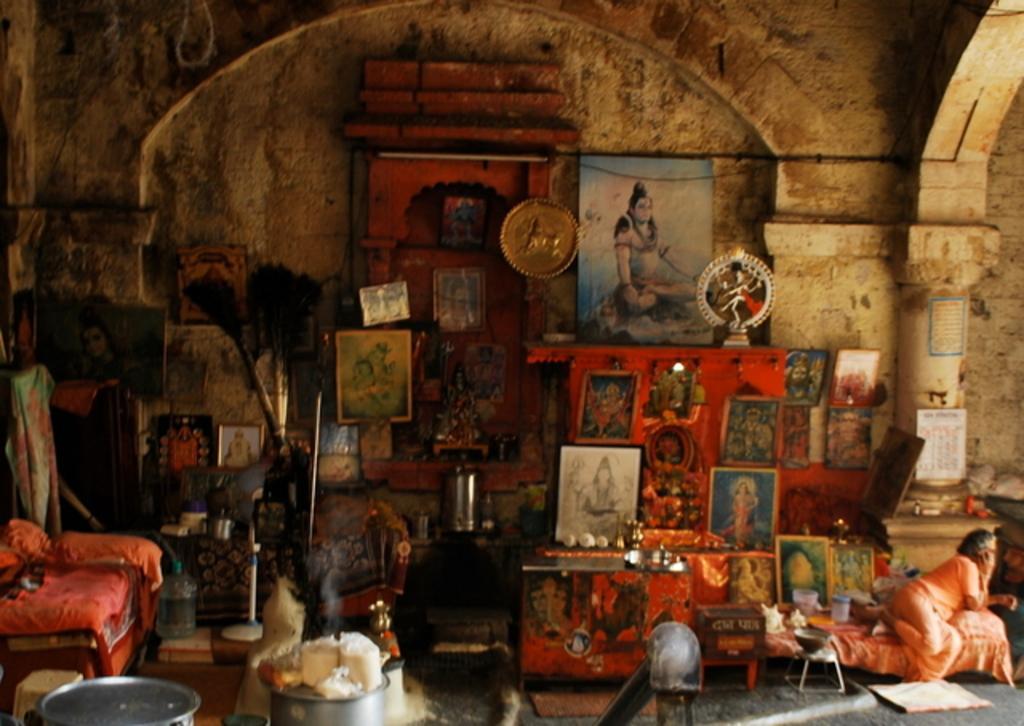In one or two sentences, can you explain what this image depicts? In this picture there are group of photo frames where few among them are attached to the wall and the remaining are placed on an object and there is a person sitting on the bed in the right corner and there are some other objects in the left corner. 